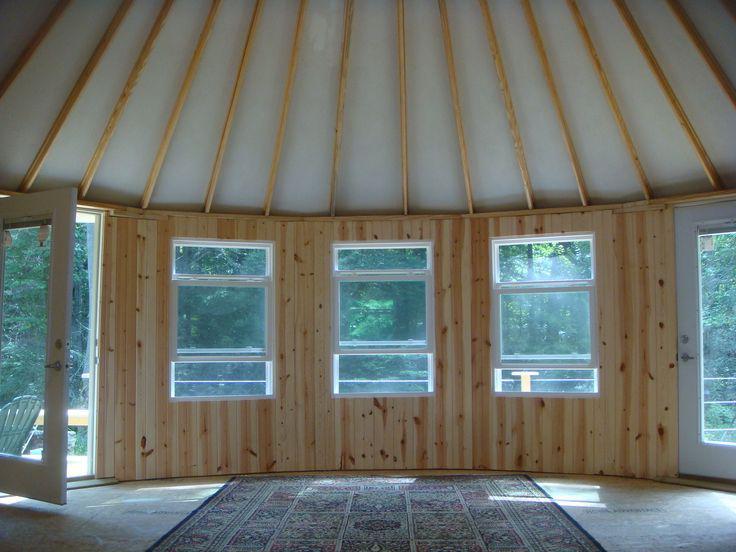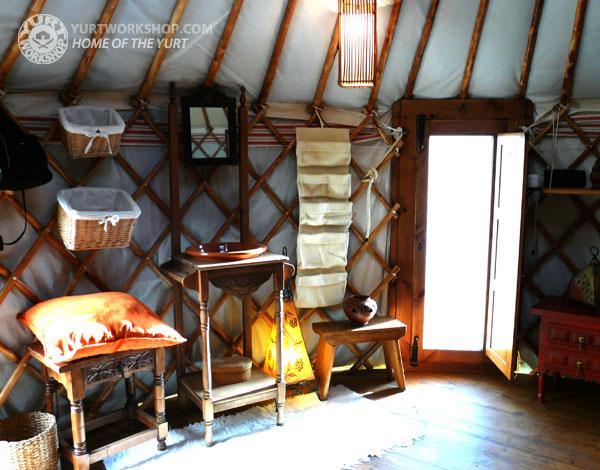The first image is the image on the left, the second image is the image on the right. For the images shown, is this caption "There is one fram on the wall in the image on the left" true? Answer yes or no. No. 